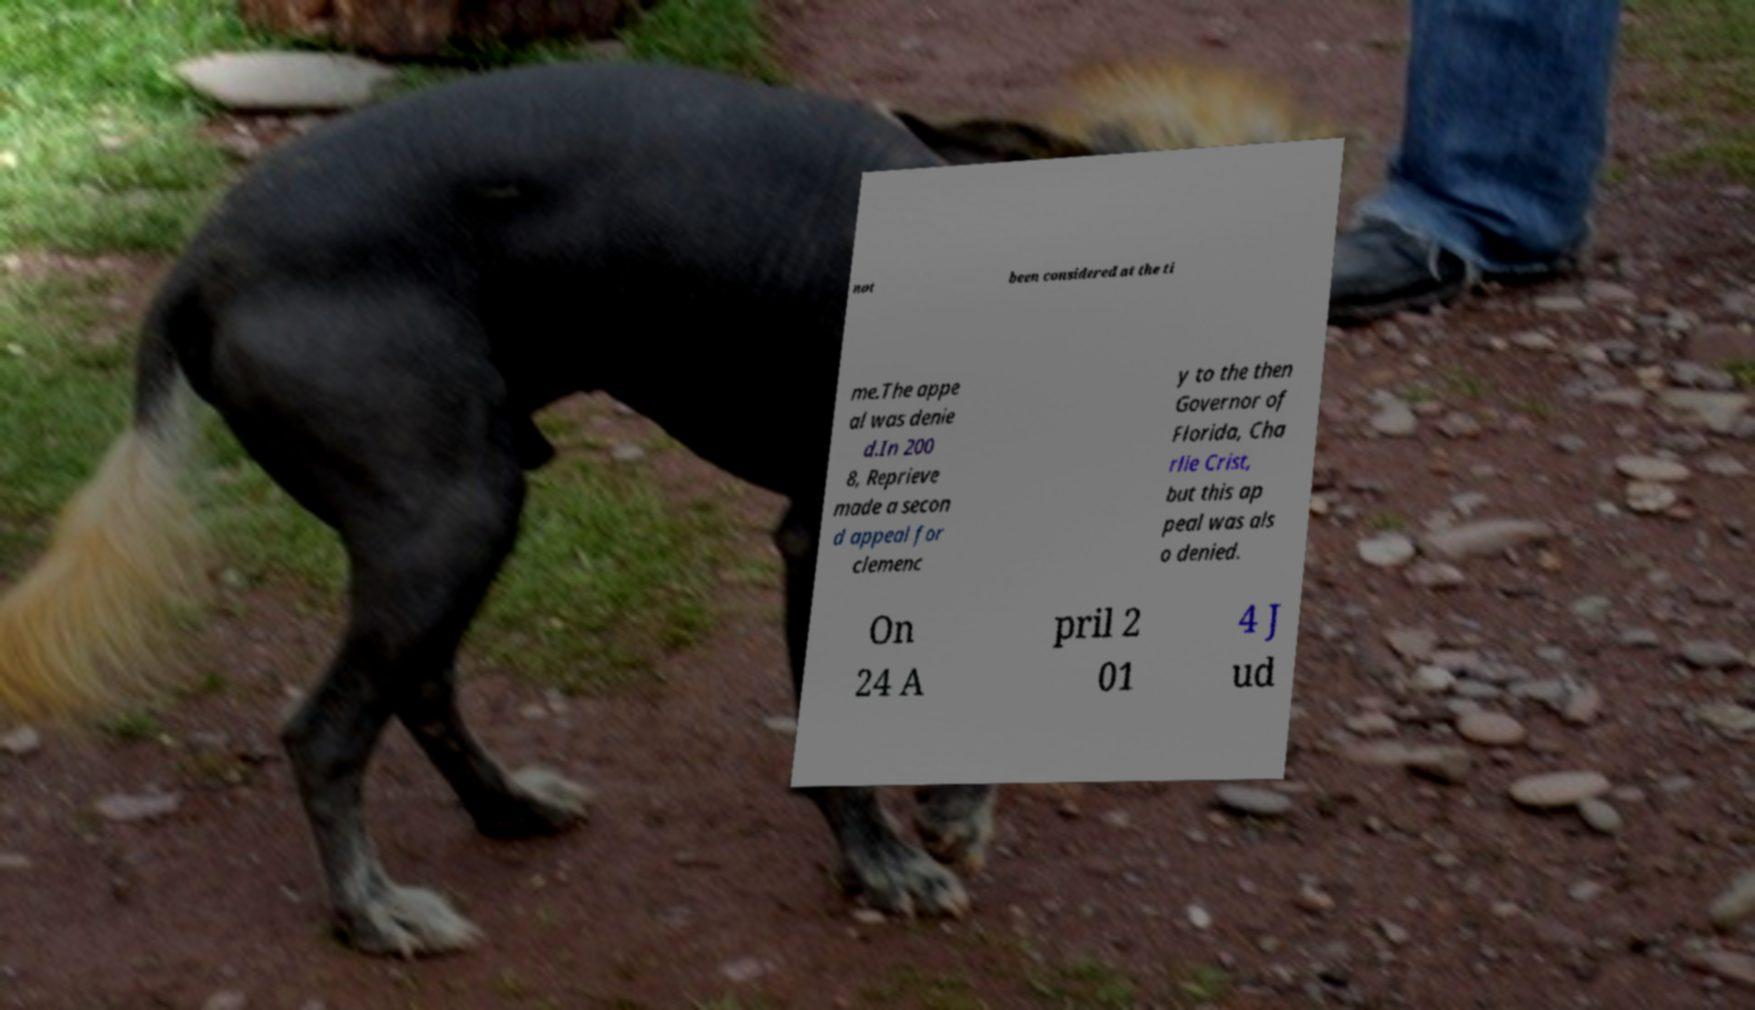I need the written content from this picture converted into text. Can you do that? not been considered at the ti me.The appe al was denie d.In 200 8, Reprieve made a secon d appeal for clemenc y to the then Governor of Florida, Cha rlie Crist, but this ap peal was als o denied. On 24 A pril 2 01 4 J ud 